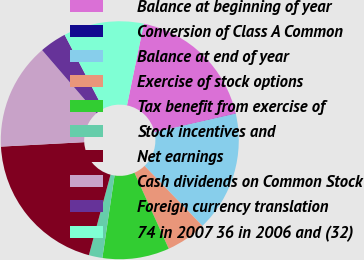Convert chart. <chart><loc_0><loc_0><loc_500><loc_500><pie_chart><fcel>Balance at beginning of year<fcel>Conversion of Class A Common<fcel>Balance at end of year<fcel>Exercise of stock options<fcel>Tax benefit from exercise of<fcel>Stock incentives and<fcel>Net earnings<fcel>Cash dividends on Common Stock<fcel>Foreign currency translation<fcel>74 in 2007 36 in 2006 and (32)<nl><fcel>18.16%<fcel>0.03%<fcel>16.35%<fcel>5.47%<fcel>9.09%<fcel>1.84%<fcel>19.97%<fcel>14.53%<fcel>3.65%<fcel>10.91%<nl></chart> 